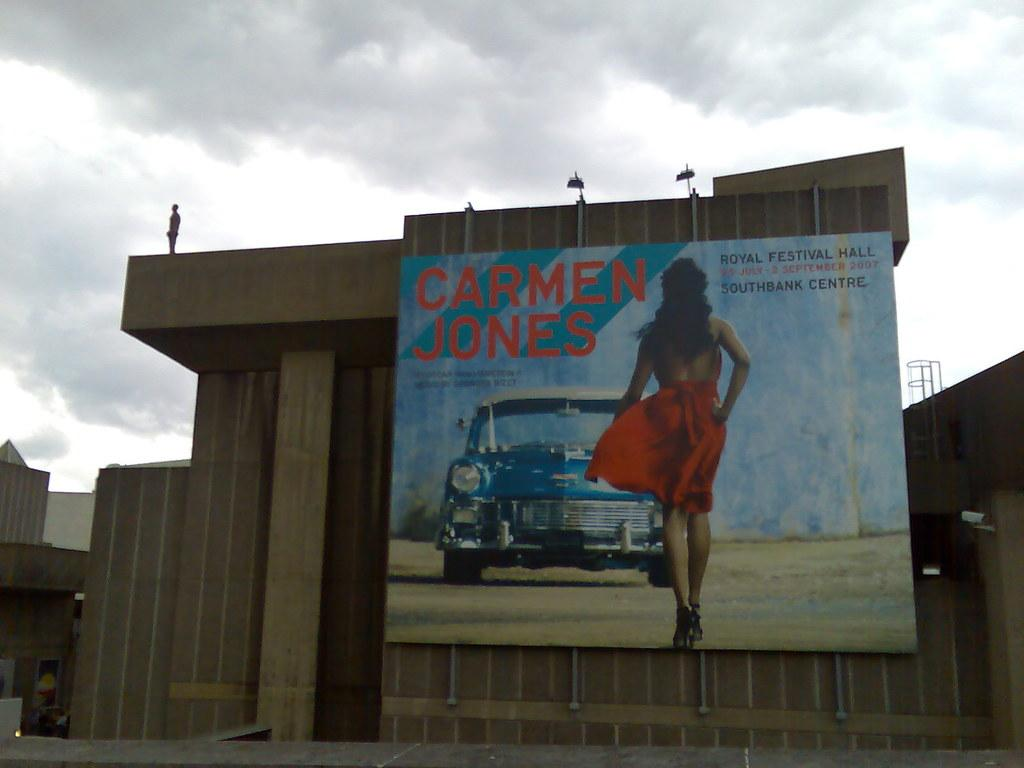<image>
Provide a brief description of the given image. An outdoor billboard with a lady in a red dress titled Carmen Jones. 